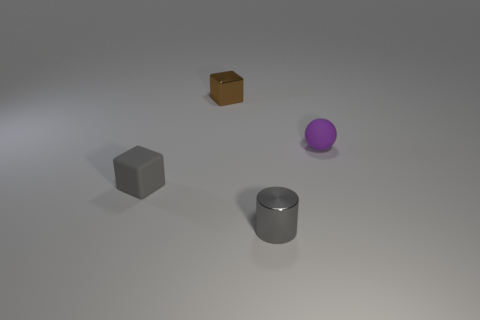How many objects are either large yellow rubber things or brown shiny cubes that are behind the matte cube?
Your answer should be very brief. 1. What shape is the thing that is in front of the small matte ball and on the left side of the small gray shiny object?
Your answer should be compact. Cube. What material is the small block that is behind the object left of the brown object?
Ensure brevity in your answer.  Metal. Do the gray thing behind the tiny gray metallic object and the brown object have the same material?
Ensure brevity in your answer.  No. There is a rubber thing left of the gray cylinder; what size is it?
Your answer should be very brief. Small. Are there any matte things that are in front of the thing that is on the right side of the small gray metal thing?
Make the answer very short. Yes. There is a metal thing behind the small rubber block; does it have the same color as the object that is right of the gray cylinder?
Give a very brief answer. No. The metal cube is what color?
Your answer should be very brief. Brown. Are there any other things of the same color as the metal block?
Your answer should be compact. No. What color is the object that is both left of the tiny gray cylinder and in front of the brown cube?
Give a very brief answer. Gray. 